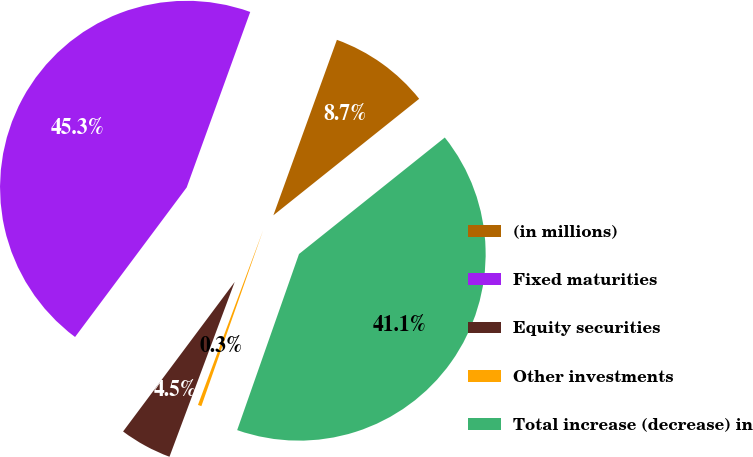Convert chart to OTSL. <chart><loc_0><loc_0><loc_500><loc_500><pie_chart><fcel>(in millions)<fcel>Fixed maturities<fcel>Equity securities<fcel>Other investments<fcel>Total increase (decrease) in<nl><fcel>8.74%<fcel>45.32%<fcel>4.52%<fcel>0.31%<fcel>41.1%<nl></chart> 